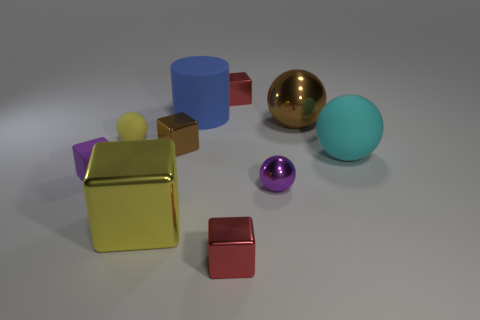Subtract all yellow cubes. How many cubes are left? 4 Subtract all small metal balls. How many balls are left? 3 Add 7 tiny purple rubber blocks. How many tiny purple rubber blocks are left? 8 Add 8 large gray objects. How many large gray objects exist? 8 Subtract 1 blue cylinders. How many objects are left? 9 Subtract all cylinders. How many objects are left? 9 Subtract 1 cubes. How many cubes are left? 4 Subtract all purple cubes. Subtract all brown balls. How many cubes are left? 4 Subtract all cyan cylinders. How many brown balls are left? 1 Subtract all big brown spheres. Subtract all large blue matte cylinders. How many objects are left? 8 